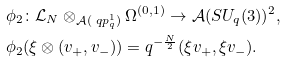Convert formula to latex. <formula><loc_0><loc_0><loc_500><loc_500>& \phi _ { 2 } \colon \mathcal { L } _ { N } \otimes _ { \mathcal { A } ( \ q p ^ { 1 } _ { q } ) } \Omega ^ { ( 0 , 1 ) } \rightarrow \mathcal { A } ( S U _ { q } ( 3 ) ) ^ { 2 } , \\ & \phi _ { 2 } ( \xi \otimes ( v _ { + } , v _ { - } ) ) = q ^ { - \frac { N } { 2 } } ( \xi v _ { + } , \xi v _ { - } ) .</formula> 